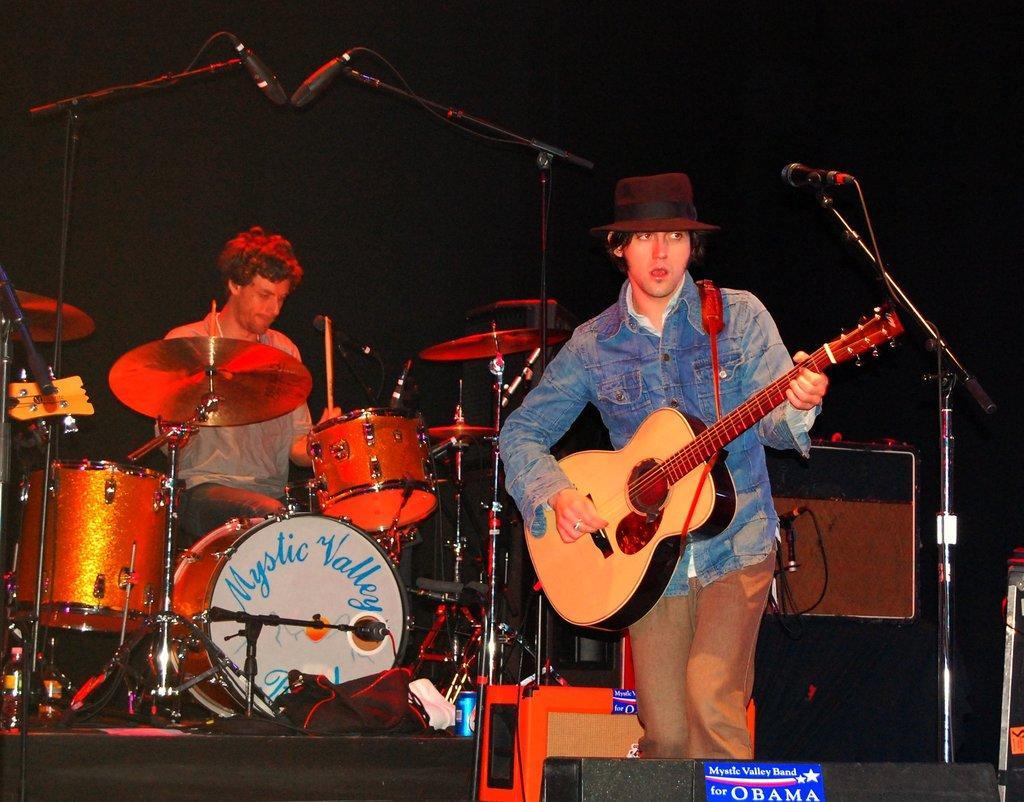Could you give a brief overview of what you see in this image? This picture is clicked in a musical concert. Man on the right side of the picture wearing blue jacket is holding guitar in his hands and playing it. In front of him, we see microphone and I think he is singing song on microphone and beside him, we see man in grey t-shirt who is sitting on chair is playing drums. 